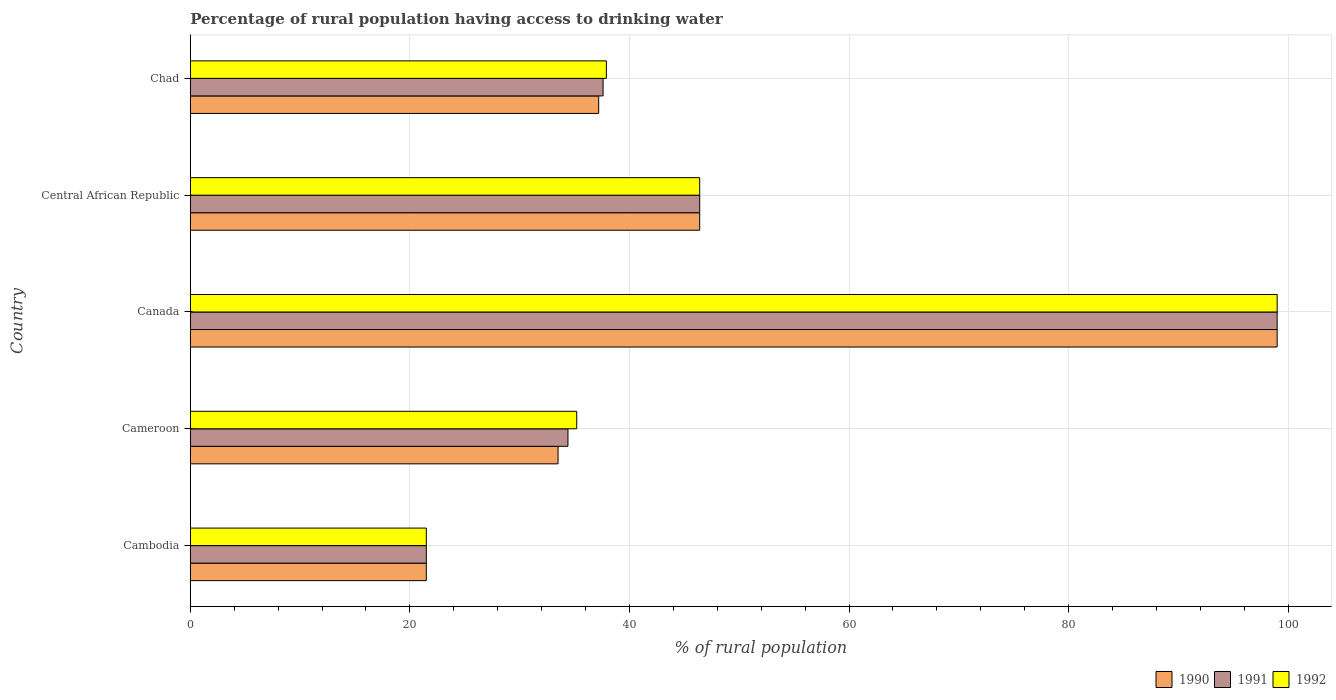How many different coloured bars are there?
Make the answer very short. 3. Are the number of bars per tick equal to the number of legend labels?
Your answer should be very brief. Yes. Are the number of bars on each tick of the Y-axis equal?
Ensure brevity in your answer.  Yes. How many bars are there on the 3rd tick from the bottom?
Ensure brevity in your answer.  3. What is the label of the 2nd group of bars from the top?
Offer a very short reply. Central African Republic. What is the percentage of rural population having access to drinking water in 1992 in Central African Republic?
Keep it short and to the point. 46.4. Across all countries, what is the minimum percentage of rural population having access to drinking water in 1991?
Ensure brevity in your answer.  21.5. In which country was the percentage of rural population having access to drinking water in 1991 maximum?
Your answer should be compact. Canada. In which country was the percentage of rural population having access to drinking water in 1992 minimum?
Provide a succinct answer. Cambodia. What is the total percentage of rural population having access to drinking water in 1990 in the graph?
Your answer should be compact. 237.6. What is the difference between the percentage of rural population having access to drinking water in 1992 in Cameroon and that in Chad?
Provide a succinct answer. -2.7. What is the difference between the percentage of rural population having access to drinking water in 1991 in Cameroon and the percentage of rural population having access to drinking water in 1992 in Cambodia?
Your answer should be compact. 12.9. What is the average percentage of rural population having access to drinking water in 1992 per country?
Provide a succinct answer. 48. What is the difference between the percentage of rural population having access to drinking water in 1990 and percentage of rural population having access to drinking water in 1991 in Central African Republic?
Offer a terse response. 0. What is the ratio of the percentage of rural population having access to drinking water in 1992 in Cambodia to that in Chad?
Ensure brevity in your answer.  0.57. What is the difference between the highest and the second highest percentage of rural population having access to drinking water in 1992?
Offer a very short reply. 52.6. What is the difference between the highest and the lowest percentage of rural population having access to drinking water in 1991?
Give a very brief answer. 77.5. Is the sum of the percentage of rural population having access to drinking water in 1992 in Canada and Chad greater than the maximum percentage of rural population having access to drinking water in 1990 across all countries?
Provide a short and direct response. Yes. What does the 2nd bar from the bottom in Cambodia represents?
Your response must be concise. 1991. Is it the case that in every country, the sum of the percentage of rural population having access to drinking water in 1990 and percentage of rural population having access to drinking water in 1991 is greater than the percentage of rural population having access to drinking water in 1992?
Provide a short and direct response. Yes. How many bars are there?
Your answer should be compact. 15. What is the difference between two consecutive major ticks on the X-axis?
Your answer should be compact. 20. Does the graph contain grids?
Your answer should be compact. Yes. Where does the legend appear in the graph?
Your answer should be very brief. Bottom right. How many legend labels are there?
Make the answer very short. 3. How are the legend labels stacked?
Your answer should be very brief. Horizontal. What is the title of the graph?
Make the answer very short. Percentage of rural population having access to drinking water. What is the label or title of the X-axis?
Your answer should be very brief. % of rural population. What is the label or title of the Y-axis?
Your answer should be very brief. Country. What is the % of rural population in 1990 in Cambodia?
Your answer should be very brief. 21.5. What is the % of rural population of 1992 in Cambodia?
Your answer should be very brief. 21.5. What is the % of rural population in 1990 in Cameroon?
Ensure brevity in your answer.  33.5. What is the % of rural population of 1991 in Cameroon?
Your answer should be very brief. 34.4. What is the % of rural population in 1992 in Cameroon?
Provide a succinct answer. 35.2. What is the % of rural population in 1992 in Canada?
Make the answer very short. 99. What is the % of rural population of 1990 in Central African Republic?
Provide a short and direct response. 46.4. What is the % of rural population in 1991 in Central African Republic?
Give a very brief answer. 46.4. What is the % of rural population of 1992 in Central African Republic?
Your answer should be very brief. 46.4. What is the % of rural population of 1990 in Chad?
Make the answer very short. 37.2. What is the % of rural population of 1991 in Chad?
Keep it short and to the point. 37.6. What is the % of rural population of 1992 in Chad?
Offer a very short reply. 37.9. Across all countries, what is the maximum % of rural population in 1990?
Your response must be concise. 99. Across all countries, what is the maximum % of rural population of 1991?
Keep it short and to the point. 99. Across all countries, what is the minimum % of rural population of 1990?
Your answer should be compact. 21.5. Across all countries, what is the minimum % of rural population in 1991?
Make the answer very short. 21.5. What is the total % of rural population in 1990 in the graph?
Keep it short and to the point. 237.6. What is the total % of rural population in 1991 in the graph?
Make the answer very short. 238.9. What is the total % of rural population in 1992 in the graph?
Keep it short and to the point. 240. What is the difference between the % of rural population in 1991 in Cambodia and that in Cameroon?
Provide a short and direct response. -12.9. What is the difference between the % of rural population of 1992 in Cambodia and that in Cameroon?
Your answer should be very brief. -13.7. What is the difference between the % of rural population in 1990 in Cambodia and that in Canada?
Provide a succinct answer. -77.5. What is the difference between the % of rural population in 1991 in Cambodia and that in Canada?
Give a very brief answer. -77.5. What is the difference between the % of rural population of 1992 in Cambodia and that in Canada?
Offer a terse response. -77.5. What is the difference between the % of rural population in 1990 in Cambodia and that in Central African Republic?
Keep it short and to the point. -24.9. What is the difference between the % of rural population of 1991 in Cambodia and that in Central African Republic?
Provide a short and direct response. -24.9. What is the difference between the % of rural population in 1992 in Cambodia and that in Central African Republic?
Keep it short and to the point. -24.9. What is the difference between the % of rural population of 1990 in Cambodia and that in Chad?
Make the answer very short. -15.7. What is the difference between the % of rural population in 1991 in Cambodia and that in Chad?
Offer a terse response. -16.1. What is the difference between the % of rural population in 1992 in Cambodia and that in Chad?
Your answer should be compact. -16.4. What is the difference between the % of rural population of 1990 in Cameroon and that in Canada?
Give a very brief answer. -65.5. What is the difference between the % of rural population in 1991 in Cameroon and that in Canada?
Provide a succinct answer. -64.6. What is the difference between the % of rural population in 1992 in Cameroon and that in Canada?
Make the answer very short. -63.8. What is the difference between the % of rural population in 1990 in Canada and that in Central African Republic?
Your answer should be compact. 52.6. What is the difference between the % of rural population of 1991 in Canada and that in Central African Republic?
Make the answer very short. 52.6. What is the difference between the % of rural population of 1992 in Canada and that in Central African Republic?
Give a very brief answer. 52.6. What is the difference between the % of rural population of 1990 in Canada and that in Chad?
Give a very brief answer. 61.8. What is the difference between the % of rural population of 1991 in Canada and that in Chad?
Your answer should be compact. 61.4. What is the difference between the % of rural population in 1992 in Canada and that in Chad?
Your answer should be very brief. 61.1. What is the difference between the % of rural population in 1990 in Cambodia and the % of rural population in 1992 in Cameroon?
Offer a very short reply. -13.7. What is the difference between the % of rural population in 1991 in Cambodia and the % of rural population in 1992 in Cameroon?
Provide a short and direct response. -13.7. What is the difference between the % of rural population of 1990 in Cambodia and the % of rural population of 1991 in Canada?
Make the answer very short. -77.5. What is the difference between the % of rural population in 1990 in Cambodia and the % of rural population in 1992 in Canada?
Give a very brief answer. -77.5. What is the difference between the % of rural population of 1991 in Cambodia and the % of rural population of 1992 in Canada?
Ensure brevity in your answer.  -77.5. What is the difference between the % of rural population in 1990 in Cambodia and the % of rural population in 1991 in Central African Republic?
Your answer should be very brief. -24.9. What is the difference between the % of rural population in 1990 in Cambodia and the % of rural population in 1992 in Central African Republic?
Make the answer very short. -24.9. What is the difference between the % of rural population of 1991 in Cambodia and the % of rural population of 1992 in Central African Republic?
Make the answer very short. -24.9. What is the difference between the % of rural population in 1990 in Cambodia and the % of rural population in 1991 in Chad?
Offer a very short reply. -16.1. What is the difference between the % of rural population in 1990 in Cambodia and the % of rural population in 1992 in Chad?
Your answer should be very brief. -16.4. What is the difference between the % of rural population in 1991 in Cambodia and the % of rural population in 1992 in Chad?
Your answer should be compact. -16.4. What is the difference between the % of rural population of 1990 in Cameroon and the % of rural population of 1991 in Canada?
Your answer should be very brief. -65.5. What is the difference between the % of rural population of 1990 in Cameroon and the % of rural population of 1992 in Canada?
Your answer should be very brief. -65.5. What is the difference between the % of rural population of 1991 in Cameroon and the % of rural population of 1992 in Canada?
Provide a short and direct response. -64.6. What is the difference between the % of rural population of 1990 in Cameroon and the % of rural population of 1992 in Central African Republic?
Your answer should be compact. -12.9. What is the difference between the % of rural population in 1990 in Canada and the % of rural population in 1991 in Central African Republic?
Offer a very short reply. 52.6. What is the difference between the % of rural population in 1990 in Canada and the % of rural population in 1992 in Central African Republic?
Offer a very short reply. 52.6. What is the difference between the % of rural population in 1991 in Canada and the % of rural population in 1992 in Central African Republic?
Provide a succinct answer. 52.6. What is the difference between the % of rural population in 1990 in Canada and the % of rural population in 1991 in Chad?
Provide a short and direct response. 61.4. What is the difference between the % of rural population in 1990 in Canada and the % of rural population in 1992 in Chad?
Ensure brevity in your answer.  61.1. What is the difference between the % of rural population of 1991 in Canada and the % of rural population of 1992 in Chad?
Give a very brief answer. 61.1. What is the difference between the % of rural population in 1990 in Central African Republic and the % of rural population in 1991 in Chad?
Give a very brief answer. 8.8. What is the difference between the % of rural population of 1990 in Central African Republic and the % of rural population of 1992 in Chad?
Give a very brief answer. 8.5. What is the difference between the % of rural population of 1991 in Central African Republic and the % of rural population of 1992 in Chad?
Your answer should be very brief. 8.5. What is the average % of rural population of 1990 per country?
Offer a very short reply. 47.52. What is the average % of rural population of 1991 per country?
Keep it short and to the point. 47.78. What is the average % of rural population in 1992 per country?
Provide a short and direct response. 48. What is the difference between the % of rural population of 1990 and % of rural population of 1991 in Cambodia?
Provide a short and direct response. 0. What is the difference between the % of rural population of 1990 and % of rural population of 1992 in Cambodia?
Give a very brief answer. 0. What is the difference between the % of rural population of 1991 and % of rural population of 1992 in Cambodia?
Offer a terse response. 0. What is the difference between the % of rural population of 1991 and % of rural population of 1992 in Cameroon?
Ensure brevity in your answer.  -0.8. What is the difference between the % of rural population of 1990 and % of rural population of 1991 in Canada?
Make the answer very short. 0. What is the difference between the % of rural population of 1991 and % of rural population of 1992 in Canada?
Provide a short and direct response. 0. What is the difference between the % of rural population of 1990 and % of rural population of 1991 in Central African Republic?
Ensure brevity in your answer.  0. What is the difference between the % of rural population in 1990 and % of rural population in 1992 in Central African Republic?
Offer a very short reply. 0. What is the difference between the % of rural population of 1991 and % of rural population of 1992 in Central African Republic?
Give a very brief answer. 0. What is the difference between the % of rural population of 1990 and % of rural population of 1992 in Chad?
Provide a succinct answer. -0.7. What is the ratio of the % of rural population in 1990 in Cambodia to that in Cameroon?
Offer a very short reply. 0.64. What is the ratio of the % of rural population of 1992 in Cambodia to that in Cameroon?
Provide a short and direct response. 0.61. What is the ratio of the % of rural population in 1990 in Cambodia to that in Canada?
Give a very brief answer. 0.22. What is the ratio of the % of rural population of 1991 in Cambodia to that in Canada?
Offer a very short reply. 0.22. What is the ratio of the % of rural population of 1992 in Cambodia to that in Canada?
Your answer should be compact. 0.22. What is the ratio of the % of rural population of 1990 in Cambodia to that in Central African Republic?
Make the answer very short. 0.46. What is the ratio of the % of rural population in 1991 in Cambodia to that in Central African Republic?
Offer a very short reply. 0.46. What is the ratio of the % of rural population of 1992 in Cambodia to that in Central African Republic?
Make the answer very short. 0.46. What is the ratio of the % of rural population of 1990 in Cambodia to that in Chad?
Make the answer very short. 0.58. What is the ratio of the % of rural population of 1991 in Cambodia to that in Chad?
Make the answer very short. 0.57. What is the ratio of the % of rural population in 1992 in Cambodia to that in Chad?
Give a very brief answer. 0.57. What is the ratio of the % of rural population of 1990 in Cameroon to that in Canada?
Ensure brevity in your answer.  0.34. What is the ratio of the % of rural population of 1991 in Cameroon to that in Canada?
Offer a very short reply. 0.35. What is the ratio of the % of rural population of 1992 in Cameroon to that in Canada?
Give a very brief answer. 0.36. What is the ratio of the % of rural population of 1990 in Cameroon to that in Central African Republic?
Provide a succinct answer. 0.72. What is the ratio of the % of rural population in 1991 in Cameroon to that in Central African Republic?
Offer a terse response. 0.74. What is the ratio of the % of rural population in 1992 in Cameroon to that in Central African Republic?
Your answer should be very brief. 0.76. What is the ratio of the % of rural population in 1990 in Cameroon to that in Chad?
Keep it short and to the point. 0.9. What is the ratio of the % of rural population of 1991 in Cameroon to that in Chad?
Ensure brevity in your answer.  0.91. What is the ratio of the % of rural population in 1992 in Cameroon to that in Chad?
Offer a terse response. 0.93. What is the ratio of the % of rural population in 1990 in Canada to that in Central African Republic?
Ensure brevity in your answer.  2.13. What is the ratio of the % of rural population of 1991 in Canada to that in Central African Republic?
Offer a very short reply. 2.13. What is the ratio of the % of rural population in 1992 in Canada to that in Central African Republic?
Make the answer very short. 2.13. What is the ratio of the % of rural population of 1990 in Canada to that in Chad?
Provide a succinct answer. 2.66. What is the ratio of the % of rural population in 1991 in Canada to that in Chad?
Give a very brief answer. 2.63. What is the ratio of the % of rural population of 1992 in Canada to that in Chad?
Your answer should be compact. 2.61. What is the ratio of the % of rural population of 1990 in Central African Republic to that in Chad?
Provide a succinct answer. 1.25. What is the ratio of the % of rural population in 1991 in Central African Republic to that in Chad?
Offer a very short reply. 1.23. What is the ratio of the % of rural population in 1992 in Central African Republic to that in Chad?
Make the answer very short. 1.22. What is the difference between the highest and the second highest % of rural population in 1990?
Your answer should be very brief. 52.6. What is the difference between the highest and the second highest % of rural population of 1991?
Provide a succinct answer. 52.6. What is the difference between the highest and the second highest % of rural population of 1992?
Provide a short and direct response. 52.6. What is the difference between the highest and the lowest % of rural population of 1990?
Keep it short and to the point. 77.5. What is the difference between the highest and the lowest % of rural population in 1991?
Give a very brief answer. 77.5. What is the difference between the highest and the lowest % of rural population in 1992?
Your answer should be very brief. 77.5. 